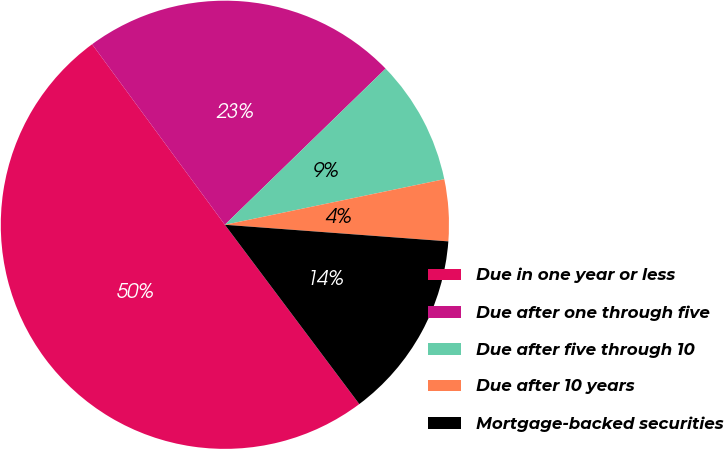<chart> <loc_0><loc_0><loc_500><loc_500><pie_chart><fcel>Due in one year or less<fcel>Due after one through five<fcel>Due after five through 10<fcel>Due after 10 years<fcel>Mortgage-backed securities<nl><fcel>50.14%<fcel>22.82%<fcel>9.01%<fcel>4.44%<fcel>13.58%<nl></chart> 